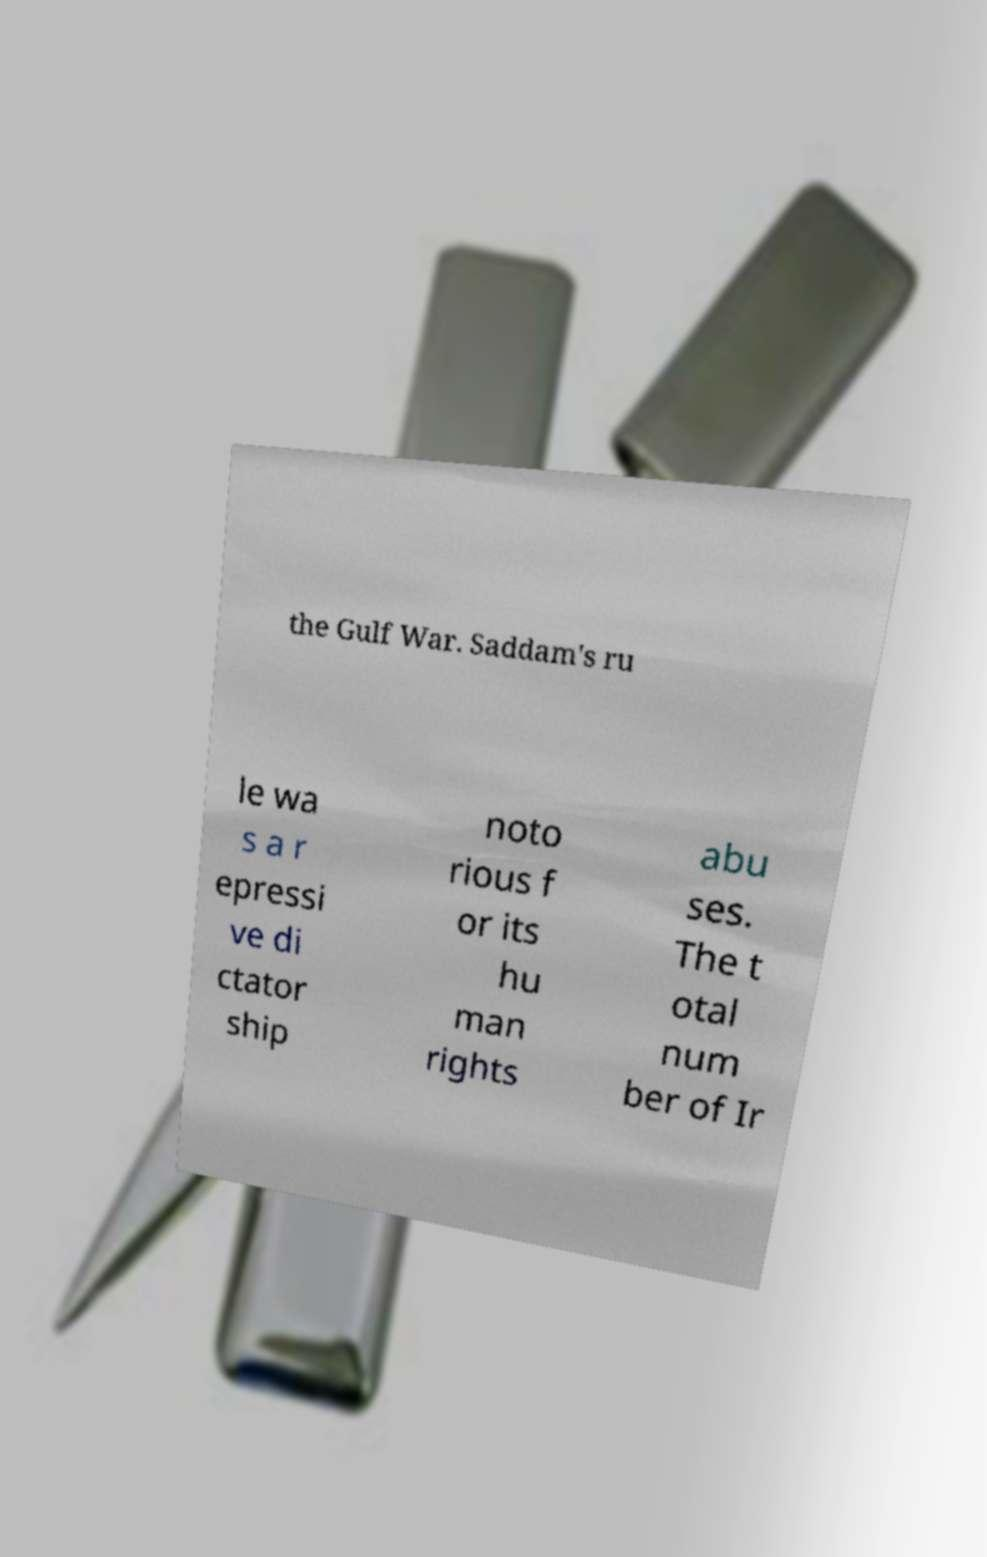I need the written content from this picture converted into text. Can you do that? the Gulf War. Saddam's ru le wa s a r epressi ve di ctator ship noto rious f or its hu man rights abu ses. The t otal num ber of Ir 